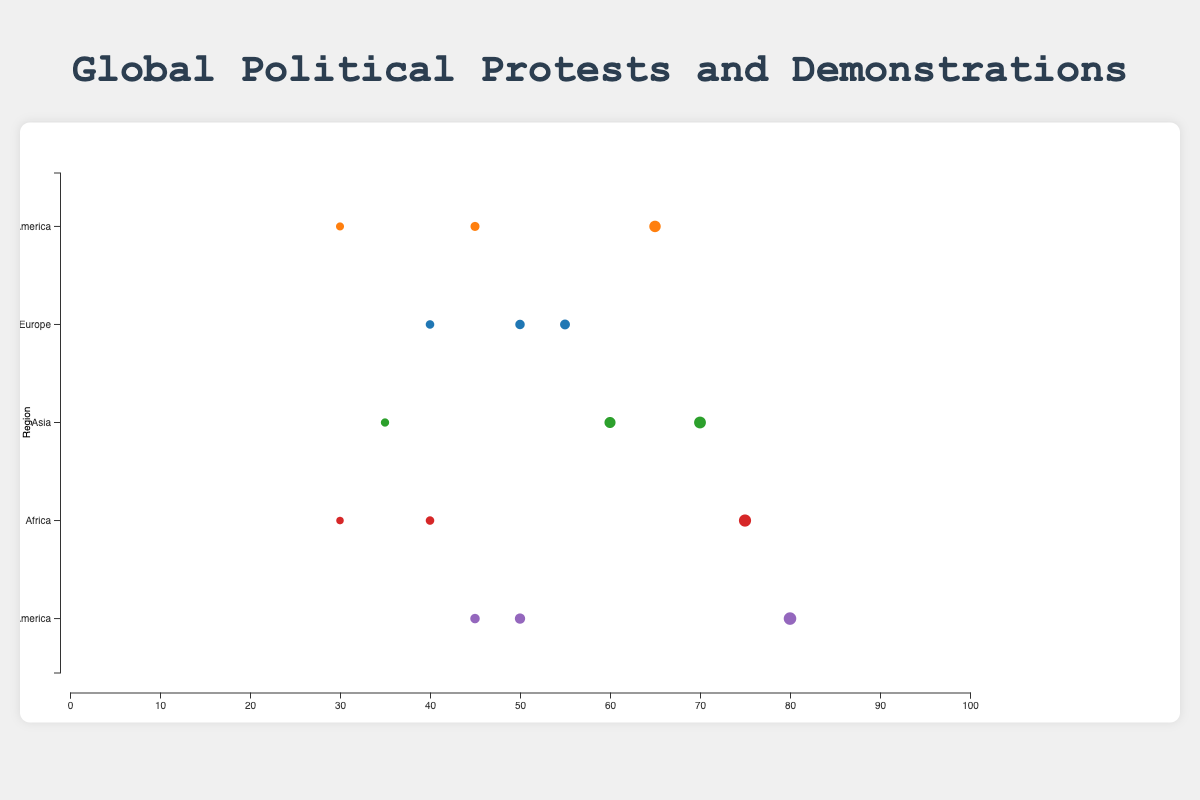Which issue has the highest frequency in North America? By looking at the bubble chart, the issue with the largest circle in the North America row represents "Police Brutality" with a frequency of 65.
Answer: Police Brutality Which region has the highest frequency of protests for Climate Change? By reviewing the bubble chart, the largest circle among all regions for the "Climate Change" issue is in Europe, with a frequency of 55.
Answer: Europe What is the difference in frequency between Police Brutality and Income Inequality protests in North America? The frequency for Police Brutality is 65 and for Income Inequality is 30. The difference is 65 - 30 = 35.
Answer: 35 Which region has the largest bubble size representing the issue of Government Corruption? Observing the size of the bubbles for "Government Corruption" across regions, Latin America has the largest bubble with a size of 210.
Answer: Latin America How many regions have at least one issue with a frequency higher than 70? Latin America has Government Corruption with 80, Asia has Democracy and Free Elections with 70, and Africa has Political Repression with 75. That's 3 regions in total.
Answer: 3 In which region is the frequency of Climate Change protests the lowest? The smallest circle for the issue of "Climate Change" is in the Africa row with a frequency of 30.
Answer: Africa What is the sum of the frequencies for Democracy and Free Elections, and Human Rights protests in Asia? The frequency for Democracy and Free Elections is 70, and for Human Rights is 60. The sum is 70 + 60 = 130.
Answer: 130 Which issue has the smallest bubble size, and in which region is it located? The smallest bubble size in the chart is for "Climate Change" in Africa, with a size of 90.
Answer: Climate Change in Africa Compare the frequency of Government Corruption protests in Europe and Latin America. Which is higher and by how much? In Europe, the frequency is 40, and in Latin America, it is 80. Latin America is higher by 80 - 40 = 40.
Answer: Latin America by 40 Identify two issues in Latin America with their frequencies and calculate their average frequency. The two issues are Government Corruption (80) and Drug Policy (50). The average is (80 + 50) / 2 = 65.
Answer: 65 